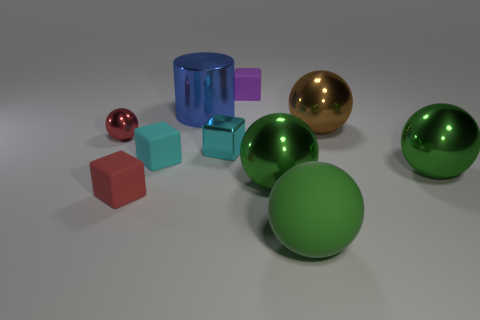Are there more green rubber objects that are in front of the big brown metallic sphere than tiny shiny objects that are on the right side of the purple rubber cube? Upon careful observation, it appears that there are indeed a significant number of green rubber objects positioned in front of the brown metallic sphere; specifically, I can discern two such items. In contrast, when examining the right side of the purple rubber cube, I find that there is only one small, shiny object. Therefore, it is accurate to affirm that there are more green rubber objects in front of the large sphere than tiny shiny ones beside the purple cube. 